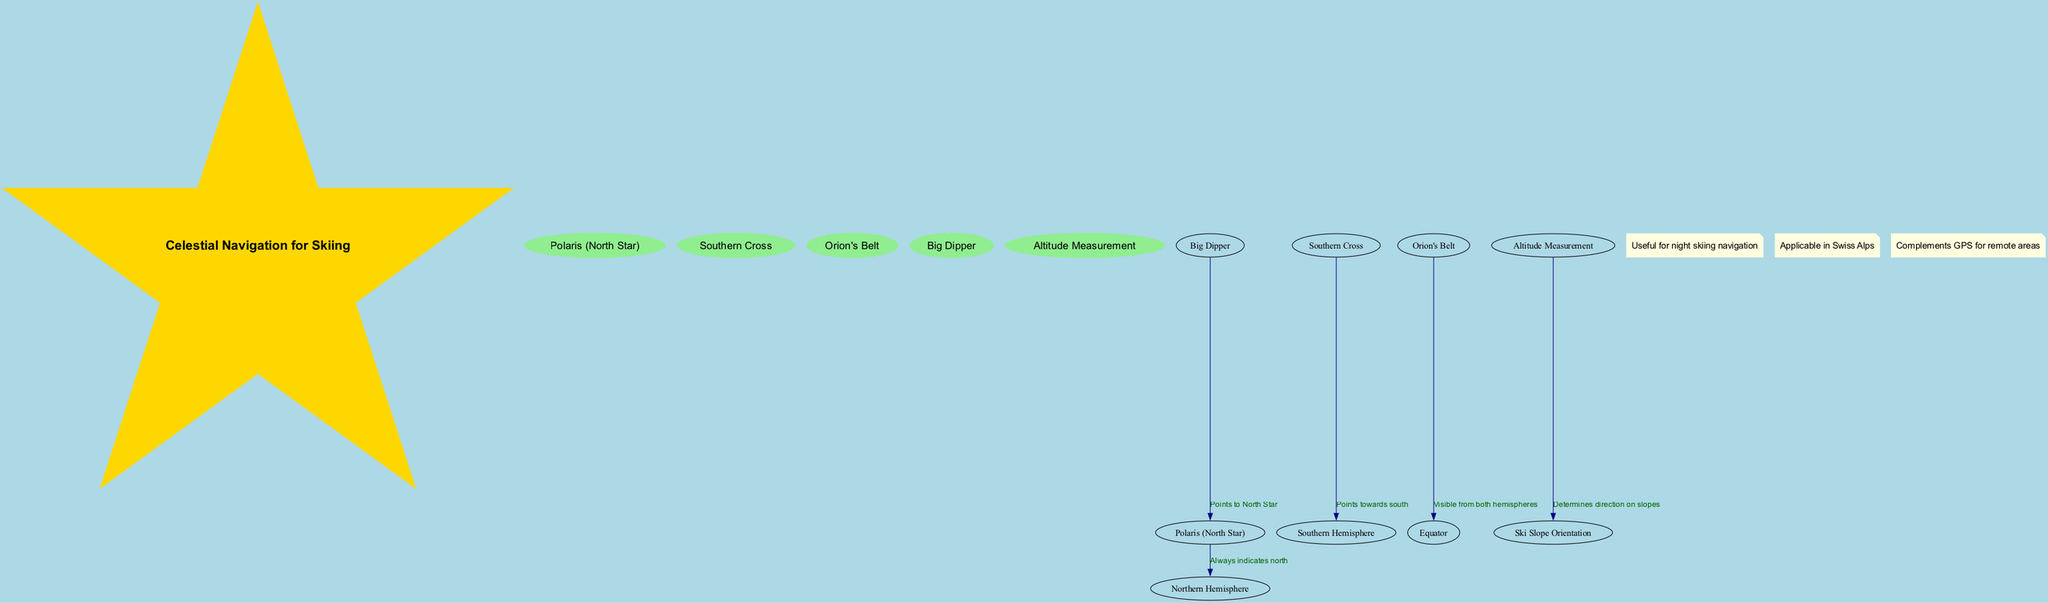What does Polaris indicate? Polaris always indicates the north direction in the Northern Hemisphere, as it is positioned directly above the North Pole.
Answer: North Which constellation points towards the south? The Southern Cross is the constellation that points towards the south in the Southern Hemisphere.
Answer: Southern Cross What does Orion's Belt signify? Orion's Belt is significant because it is visible from both the Northern and Southern Hemispheres, thus indicating the Equator's position.
Answer: Equator How many key elements are present in the diagram? There are five key elements listed in the diagram: Polaris, Southern Cross, Orion's Belt, Big Dipper, and Altitude Measurement. This is confirmed by counting them in the diagram.
Answer: Five Which element determines the direction on ski slopes? Altitude Measurement is the key element that helps to determine the direction on ski slopes, as indicated by its connection to Ski Slope Orientation.
Answer: Altitude Measurement What does the Big Dipper point to? The Big Dipper points to the North Star, Polaris, helping adventurers navigate towards true north in the Northern Hemisphere.
Answer: North Star How is the Southern Cross used in navigation? The Southern Cross is utilized in navigation by pointing directly towards the south, which can be applied to orient oneself in the Southern Hemisphere.
Answer: Points towards south What additional information is provided about the usefulness of this navigation method? It mentions that this celestial navigation is useful for night skiing navigation, is applicable in the Swiss Alps, and complements GPS for remote areas, providing critical backup for electronic navigation tools.
Answer: Useful for night skiing navigation How does the Big Dipper relate to Polaris? The Big Dipper has a direct connection that indicates it points to Polaris, allowing navigation towards the North Star from its position in the sky.
Answer: Points to North Star 